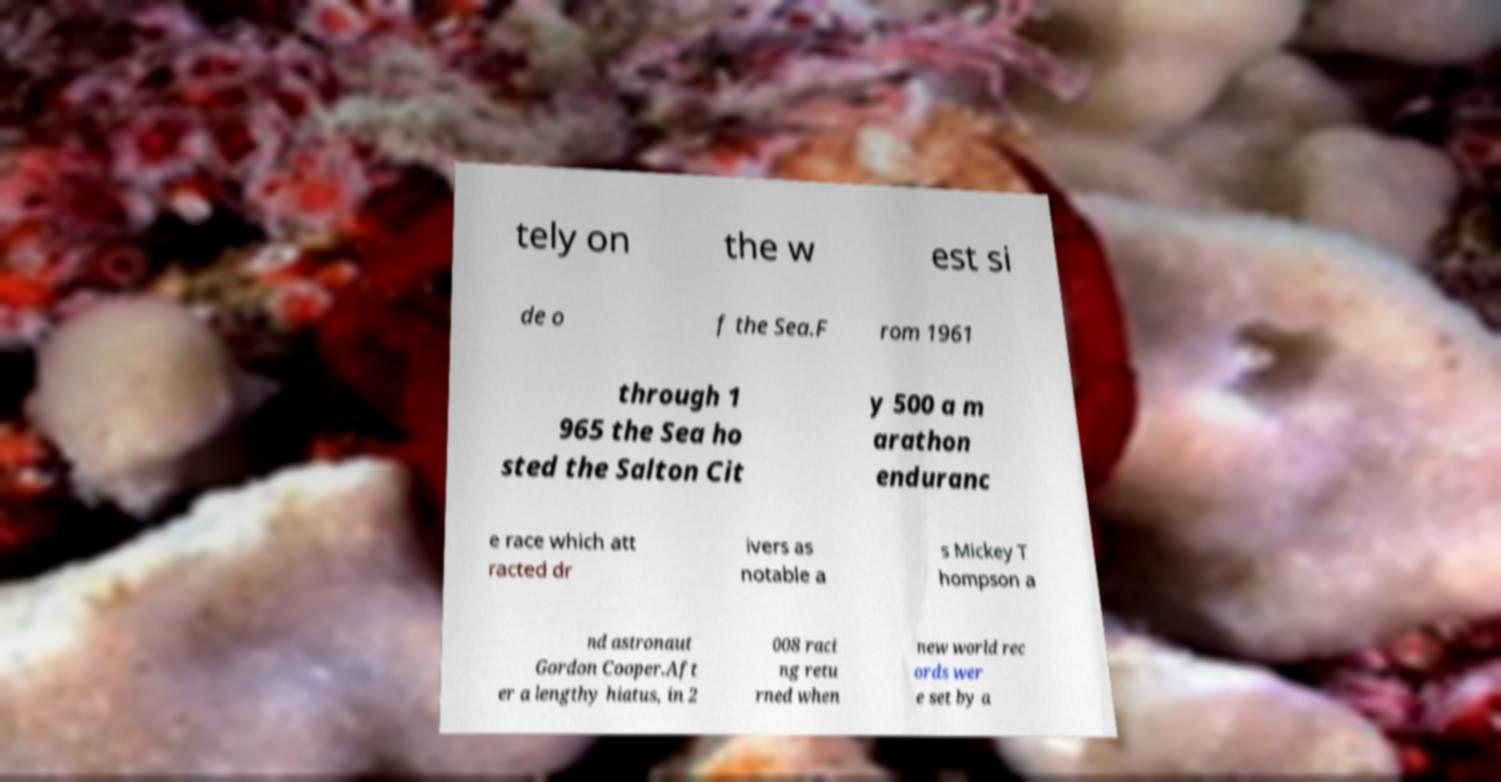Could you extract and type out the text from this image? tely on the w est si de o f the Sea.F rom 1961 through 1 965 the Sea ho sted the Salton Cit y 500 a m arathon enduranc e race which att racted dr ivers as notable a s Mickey T hompson a nd astronaut Gordon Cooper.Aft er a lengthy hiatus, in 2 008 raci ng retu rned when new world rec ords wer e set by a 